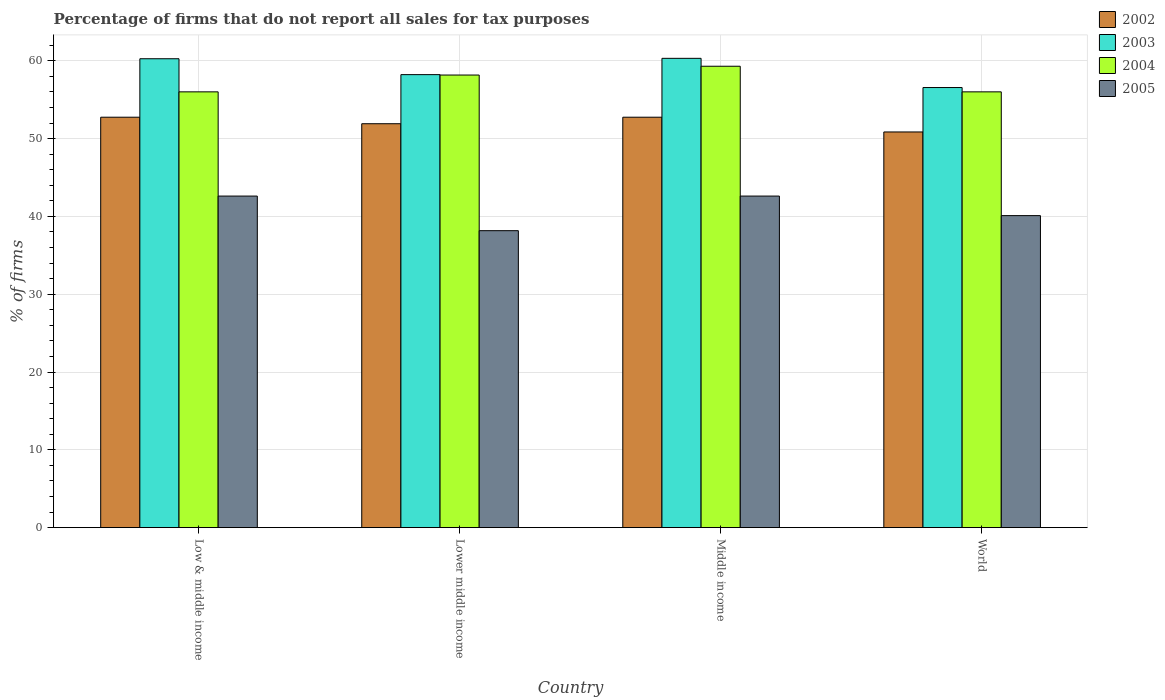How many groups of bars are there?
Offer a terse response. 4. Are the number of bars per tick equal to the number of legend labels?
Your answer should be compact. Yes. How many bars are there on the 1st tick from the left?
Make the answer very short. 4. What is the label of the 1st group of bars from the left?
Keep it short and to the point. Low & middle income. In how many cases, is the number of bars for a given country not equal to the number of legend labels?
Provide a short and direct response. 0. What is the percentage of firms that do not report all sales for tax purposes in 2003 in Low & middle income?
Offer a terse response. 60.26. Across all countries, what is the maximum percentage of firms that do not report all sales for tax purposes in 2003?
Give a very brief answer. 60.31. Across all countries, what is the minimum percentage of firms that do not report all sales for tax purposes in 2005?
Offer a terse response. 38.16. In which country was the percentage of firms that do not report all sales for tax purposes in 2002 minimum?
Make the answer very short. World. What is the total percentage of firms that do not report all sales for tax purposes in 2002 in the graph?
Offer a terse response. 208.25. What is the difference between the percentage of firms that do not report all sales for tax purposes in 2002 in Low & middle income and the percentage of firms that do not report all sales for tax purposes in 2003 in World?
Offer a very short reply. -3.81. What is the average percentage of firms that do not report all sales for tax purposes in 2002 per country?
Keep it short and to the point. 52.06. What is the difference between the percentage of firms that do not report all sales for tax purposes of/in 2004 and percentage of firms that do not report all sales for tax purposes of/in 2003 in Lower middle income?
Provide a short and direct response. -0.05. In how many countries, is the percentage of firms that do not report all sales for tax purposes in 2002 greater than 20 %?
Your response must be concise. 4. What is the ratio of the percentage of firms that do not report all sales for tax purposes in 2004 in Low & middle income to that in Middle income?
Offer a terse response. 0.94. What is the difference between the highest and the second highest percentage of firms that do not report all sales for tax purposes in 2002?
Provide a short and direct response. -0.84. What is the difference between the highest and the lowest percentage of firms that do not report all sales for tax purposes in 2003?
Your answer should be very brief. 3.75. Is the sum of the percentage of firms that do not report all sales for tax purposes in 2002 in Middle income and World greater than the maximum percentage of firms that do not report all sales for tax purposes in 2005 across all countries?
Give a very brief answer. Yes. Is it the case that in every country, the sum of the percentage of firms that do not report all sales for tax purposes in 2003 and percentage of firms that do not report all sales for tax purposes in 2002 is greater than the sum of percentage of firms that do not report all sales for tax purposes in 2004 and percentage of firms that do not report all sales for tax purposes in 2005?
Your answer should be compact. No. What does the 1st bar from the left in Middle income represents?
Give a very brief answer. 2002. What does the 2nd bar from the right in Middle income represents?
Your answer should be very brief. 2004. Are all the bars in the graph horizontal?
Your answer should be compact. No. Does the graph contain any zero values?
Provide a short and direct response. No. How many legend labels are there?
Your response must be concise. 4. What is the title of the graph?
Your answer should be very brief. Percentage of firms that do not report all sales for tax purposes. What is the label or title of the X-axis?
Provide a succinct answer. Country. What is the label or title of the Y-axis?
Give a very brief answer. % of firms. What is the % of firms of 2002 in Low & middle income?
Your answer should be very brief. 52.75. What is the % of firms of 2003 in Low & middle income?
Offer a terse response. 60.26. What is the % of firms in 2004 in Low & middle income?
Provide a succinct answer. 56.01. What is the % of firms of 2005 in Low & middle income?
Your response must be concise. 42.61. What is the % of firms in 2002 in Lower middle income?
Make the answer very short. 51.91. What is the % of firms in 2003 in Lower middle income?
Your response must be concise. 58.22. What is the % of firms in 2004 in Lower middle income?
Your answer should be very brief. 58.16. What is the % of firms in 2005 in Lower middle income?
Your response must be concise. 38.16. What is the % of firms of 2002 in Middle income?
Your response must be concise. 52.75. What is the % of firms in 2003 in Middle income?
Make the answer very short. 60.31. What is the % of firms in 2004 in Middle income?
Your answer should be compact. 59.3. What is the % of firms in 2005 in Middle income?
Keep it short and to the point. 42.61. What is the % of firms of 2002 in World?
Offer a terse response. 50.85. What is the % of firms of 2003 in World?
Your answer should be very brief. 56.56. What is the % of firms in 2004 in World?
Your answer should be compact. 56.01. What is the % of firms in 2005 in World?
Keep it short and to the point. 40.1. Across all countries, what is the maximum % of firms in 2002?
Ensure brevity in your answer.  52.75. Across all countries, what is the maximum % of firms of 2003?
Keep it short and to the point. 60.31. Across all countries, what is the maximum % of firms in 2004?
Offer a terse response. 59.3. Across all countries, what is the maximum % of firms of 2005?
Your answer should be very brief. 42.61. Across all countries, what is the minimum % of firms of 2002?
Your response must be concise. 50.85. Across all countries, what is the minimum % of firms of 2003?
Your response must be concise. 56.56. Across all countries, what is the minimum % of firms of 2004?
Keep it short and to the point. 56.01. Across all countries, what is the minimum % of firms in 2005?
Make the answer very short. 38.16. What is the total % of firms in 2002 in the graph?
Your answer should be very brief. 208.25. What is the total % of firms of 2003 in the graph?
Offer a terse response. 235.35. What is the total % of firms of 2004 in the graph?
Your response must be concise. 229.47. What is the total % of firms of 2005 in the graph?
Ensure brevity in your answer.  163.48. What is the difference between the % of firms in 2002 in Low & middle income and that in Lower middle income?
Your answer should be very brief. 0.84. What is the difference between the % of firms of 2003 in Low & middle income and that in Lower middle income?
Offer a terse response. 2.04. What is the difference between the % of firms of 2004 in Low & middle income and that in Lower middle income?
Give a very brief answer. -2.16. What is the difference between the % of firms in 2005 in Low & middle income and that in Lower middle income?
Your response must be concise. 4.45. What is the difference between the % of firms in 2003 in Low & middle income and that in Middle income?
Your answer should be very brief. -0.05. What is the difference between the % of firms of 2004 in Low & middle income and that in Middle income?
Ensure brevity in your answer.  -3.29. What is the difference between the % of firms in 2005 in Low & middle income and that in Middle income?
Your response must be concise. 0. What is the difference between the % of firms of 2002 in Low & middle income and that in World?
Offer a terse response. 1.89. What is the difference between the % of firms of 2003 in Low & middle income and that in World?
Ensure brevity in your answer.  3.7. What is the difference between the % of firms in 2005 in Low & middle income and that in World?
Give a very brief answer. 2.51. What is the difference between the % of firms of 2002 in Lower middle income and that in Middle income?
Give a very brief answer. -0.84. What is the difference between the % of firms in 2003 in Lower middle income and that in Middle income?
Offer a terse response. -2.09. What is the difference between the % of firms in 2004 in Lower middle income and that in Middle income?
Offer a very short reply. -1.13. What is the difference between the % of firms of 2005 in Lower middle income and that in Middle income?
Offer a very short reply. -4.45. What is the difference between the % of firms in 2002 in Lower middle income and that in World?
Keep it short and to the point. 1.06. What is the difference between the % of firms of 2003 in Lower middle income and that in World?
Keep it short and to the point. 1.66. What is the difference between the % of firms in 2004 in Lower middle income and that in World?
Offer a terse response. 2.16. What is the difference between the % of firms in 2005 in Lower middle income and that in World?
Ensure brevity in your answer.  -1.94. What is the difference between the % of firms of 2002 in Middle income and that in World?
Make the answer very short. 1.89. What is the difference between the % of firms of 2003 in Middle income and that in World?
Make the answer very short. 3.75. What is the difference between the % of firms in 2004 in Middle income and that in World?
Your answer should be very brief. 3.29. What is the difference between the % of firms in 2005 in Middle income and that in World?
Give a very brief answer. 2.51. What is the difference between the % of firms in 2002 in Low & middle income and the % of firms in 2003 in Lower middle income?
Keep it short and to the point. -5.47. What is the difference between the % of firms of 2002 in Low & middle income and the % of firms of 2004 in Lower middle income?
Give a very brief answer. -5.42. What is the difference between the % of firms in 2002 in Low & middle income and the % of firms in 2005 in Lower middle income?
Make the answer very short. 14.58. What is the difference between the % of firms in 2003 in Low & middle income and the % of firms in 2004 in Lower middle income?
Ensure brevity in your answer.  2.1. What is the difference between the % of firms of 2003 in Low & middle income and the % of firms of 2005 in Lower middle income?
Your answer should be compact. 22.1. What is the difference between the % of firms in 2004 in Low & middle income and the % of firms in 2005 in Lower middle income?
Keep it short and to the point. 17.84. What is the difference between the % of firms in 2002 in Low & middle income and the % of firms in 2003 in Middle income?
Provide a short and direct response. -7.57. What is the difference between the % of firms in 2002 in Low & middle income and the % of firms in 2004 in Middle income?
Your response must be concise. -6.55. What is the difference between the % of firms of 2002 in Low & middle income and the % of firms of 2005 in Middle income?
Your response must be concise. 10.13. What is the difference between the % of firms of 2003 in Low & middle income and the % of firms of 2004 in Middle income?
Provide a short and direct response. 0.96. What is the difference between the % of firms of 2003 in Low & middle income and the % of firms of 2005 in Middle income?
Give a very brief answer. 17.65. What is the difference between the % of firms of 2004 in Low & middle income and the % of firms of 2005 in Middle income?
Offer a terse response. 13.39. What is the difference between the % of firms in 2002 in Low & middle income and the % of firms in 2003 in World?
Give a very brief answer. -3.81. What is the difference between the % of firms in 2002 in Low & middle income and the % of firms in 2004 in World?
Offer a terse response. -3.26. What is the difference between the % of firms of 2002 in Low & middle income and the % of firms of 2005 in World?
Your response must be concise. 12.65. What is the difference between the % of firms in 2003 in Low & middle income and the % of firms in 2004 in World?
Give a very brief answer. 4.25. What is the difference between the % of firms in 2003 in Low & middle income and the % of firms in 2005 in World?
Keep it short and to the point. 20.16. What is the difference between the % of firms of 2004 in Low & middle income and the % of firms of 2005 in World?
Your response must be concise. 15.91. What is the difference between the % of firms in 2002 in Lower middle income and the % of firms in 2003 in Middle income?
Give a very brief answer. -8.4. What is the difference between the % of firms in 2002 in Lower middle income and the % of firms in 2004 in Middle income?
Provide a succinct answer. -7.39. What is the difference between the % of firms of 2002 in Lower middle income and the % of firms of 2005 in Middle income?
Provide a succinct answer. 9.3. What is the difference between the % of firms in 2003 in Lower middle income and the % of firms in 2004 in Middle income?
Provide a succinct answer. -1.08. What is the difference between the % of firms of 2003 in Lower middle income and the % of firms of 2005 in Middle income?
Your response must be concise. 15.61. What is the difference between the % of firms of 2004 in Lower middle income and the % of firms of 2005 in Middle income?
Give a very brief answer. 15.55. What is the difference between the % of firms in 2002 in Lower middle income and the % of firms in 2003 in World?
Your answer should be compact. -4.65. What is the difference between the % of firms in 2002 in Lower middle income and the % of firms in 2004 in World?
Your answer should be compact. -4.1. What is the difference between the % of firms of 2002 in Lower middle income and the % of firms of 2005 in World?
Provide a short and direct response. 11.81. What is the difference between the % of firms of 2003 in Lower middle income and the % of firms of 2004 in World?
Offer a terse response. 2.21. What is the difference between the % of firms in 2003 in Lower middle income and the % of firms in 2005 in World?
Offer a terse response. 18.12. What is the difference between the % of firms of 2004 in Lower middle income and the % of firms of 2005 in World?
Ensure brevity in your answer.  18.07. What is the difference between the % of firms of 2002 in Middle income and the % of firms of 2003 in World?
Give a very brief answer. -3.81. What is the difference between the % of firms of 2002 in Middle income and the % of firms of 2004 in World?
Make the answer very short. -3.26. What is the difference between the % of firms in 2002 in Middle income and the % of firms in 2005 in World?
Your answer should be compact. 12.65. What is the difference between the % of firms in 2003 in Middle income and the % of firms in 2004 in World?
Make the answer very short. 4.31. What is the difference between the % of firms in 2003 in Middle income and the % of firms in 2005 in World?
Give a very brief answer. 20.21. What is the difference between the % of firms of 2004 in Middle income and the % of firms of 2005 in World?
Keep it short and to the point. 19.2. What is the average % of firms of 2002 per country?
Provide a succinct answer. 52.06. What is the average % of firms of 2003 per country?
Provide a succinct answer. 58.84. What is the average % of firms in 2004 per country?
Make the answer very short. 57.37. What is the average % of firms in 2005 per country?
Give a very brief answer. 40.87. What is the difference between the % of firms in 2002 and % of firms in 2003 in Low & middle income?
Offer a very short reply. -7.51. What is the difference between the % of firms of 2002 and % of firms of 2004 in Low & middle income?
Provide a short and direct response. -3.26. What is the difference between the % of firms in 2002 and % of firms in 2005 in Low & middle income?
Your answer should be compact. 10.13. What is the difference between the % of firms of 2003 and % of firms of 2004 in Low & middle income?
Keep it short and to the point. 4.25. What is the difference between the % of firms of 2003 and % of firms of 2005 in Low & middle income?
Provide a succinct answer. 17.65. What is the difference between the % of firms in 2004 and % of firms in 2005 in Low & middle income?
Keep it short and to the point. 13.39. What is the difference between the % of firms in 2002 and % of firms in 2003 in Lower middle income?
Your answer should be very brief. -6.31. What is the difference between the % of firms in 2002 and % of firms in 2004 in Lower middle income?
Provide a short and direct response. -6.26. What is the difference between the % of firms of 2002 and % of firms of 2005 in Lower middle income?
Ensure brevity in your answer.  13.75. What is the difference between the % of firms of 2003 and % of firms of 2004 in Lower middle income?
Your answer should be very brief. 0.05. What is the difference between the % of firms of 2003 and % of firms of 2005 in Lower middle income?
Provide a short and direct response. 20.06. What is the difference between the % of firms of 2004 and % of firms of 2005 in Lower middle income?
Ensure brevity in your answer.  20. What is the difference between the % of firms of 2002 and % of firms of 2003 in Middle income?
Offer a terse response. -7.57. What is the difference between the % of firms in 2002 and % of firms in 2004 in Middle income?
Your answer should be very brief. -6.55. What is the difference between the % of firms of 2002 and % of firms of 2005 in Middle income?
Ensure brevity in your answer.  10.13. What is the difference between the % of firms of 2003 and % of firms of 2004 in Middle income?
Your response must be concise. 1.02. What is the difference between the % of firms in 2003 and % of firms in 2005 in Middle income?
Make the answer very short. 17.7. What is the difference between the % of firms in 2004 and % of firms in 2005 in Middle income?
Keep it short and to the point. 16.69. What is the difference between the % of firms in 2002 and % of firms in 2003 in World?
Ensure brevity in your answer.  -5.71. What is the difference between the % of firms of 2002 and % of firms of 2004 in World?
Provide a succinct answer. -5.15. What is the difference between the % of firms of 2002 and % of firms of 2005 in World?
Your answer should be very brief. 10.75. What is the difference between the % of firms in 2003 and % of firms in 2004 in World?
Ensure brevity in your answer.  0.56. What is the difference between the % of firms in 2003 and % of firms in 2005 in World?
Offer a terse response. 16.46. What is the difference between the % of firms in 2004 and % of firms in 2005 in World?
Your answer should be compact. 15.91. What is the ratio of the % of firms in 2002 in Low & middle income to that in Lower middle income?
Keep it short and to the point. 1.02. What is the ratio of the % of firms in 2003 in Low & middle income to that in Lower middle income?
Your response must be concise. 1.04. What is the ratio of the % of firms of 2004 in Low & middle income to that in Lower middle income?
Ensure brevity in your answer.  0.96. What is the ratio of the % of firms of 2005 in Low & middle income to that in Lower middle income?
Keep it short and to the point. 1.12. What is the ratio of the % of firms of 2004 in Low & middle income to that in Middle income?
Give a very brief answer. 0.94. What is the ratio of the % of firms in 2002 in Low & middle income to that in World?
Keep it short and to the point. 1.04. What is the ratio of the % of firms of 2003 in Low & middle income to that in World?
Offer a terse response. 1.07. What is the ratio of the % of firms of 2005 in Low & middle income to that in World?
Make the answer very short. 1.06. What is the ratio of the % of firms in 2002 in Lower middle income to that in Middle income?
Offer a very short reply. 0.98. What is the ratio of the % of firms in 2003 in Lower middle income to that in Middle income?
Your response must be concise. 0.97. What is the ratio of the % of firms in 2004 in Lower middle income to that in Middle income?
Keep it short and to the point. 0.98. What is the ratio of the % of firms in 2005 in Lower middle income to that in Middle income?
Give a very brief answer. 0.9. What is the ratio of the % of firms of 2002 in Lower middle income to that in World?
Provide a succinct answer. 1.02. What is the ratio of the % of firms in 2003 in Lower middle income to that in World?
Your answer should be very brief. 1.03. What is the ratio of the % of firms in 2004 in Lower middle income to that in World?
Provide a short and direct response. 1.04. What is the ratio of the % of firms of 2005 in Lower middle income to that in World?
Your answer should be compact. 0.95. What is the ratio of the % of firms in 2002 in Middle income to that in World?
Ensure brevity in your answer.  1.04. What is the ratio of the % of firms of 2003 in Middle income to that in World?
Make the answer very short. 1.07. What is the ratio of the % of firms of 2004 in Middle income to that in World?
Keep it short and to the point. 1.06. What is the ratio of the % of firms in 2005 in Middle income to that in World?
Ensure brevity in your answer.  1.06. What is the difference between the highest and the second highest % of firms of 2002?
Your answer should be compact. 0. What is the difference between the highest and the second highest % of firms of 2003?
Provide a succinct answer. 0.05. What is the difference between the highest and the second highest % of firms of 2004?
Offer a terse response. 1.13. What is the difference between the highest and the second highest % of firms in 2005?
Give a very brief answer. 0. What is the difference between the highest and the lowest % of firms of 2002?
Provide a short and direct response. 1.89. What is the difference between the highest and the lowest % of firms of 2003?
Your response must be concise. 3.75. What is the difference between the highest and the lowest % of firms of 2004?
Your response must be concise. 3.29. What is the difference between the highest and the lowest % of firms in 2005?
Offer a terse response. 4.45. 